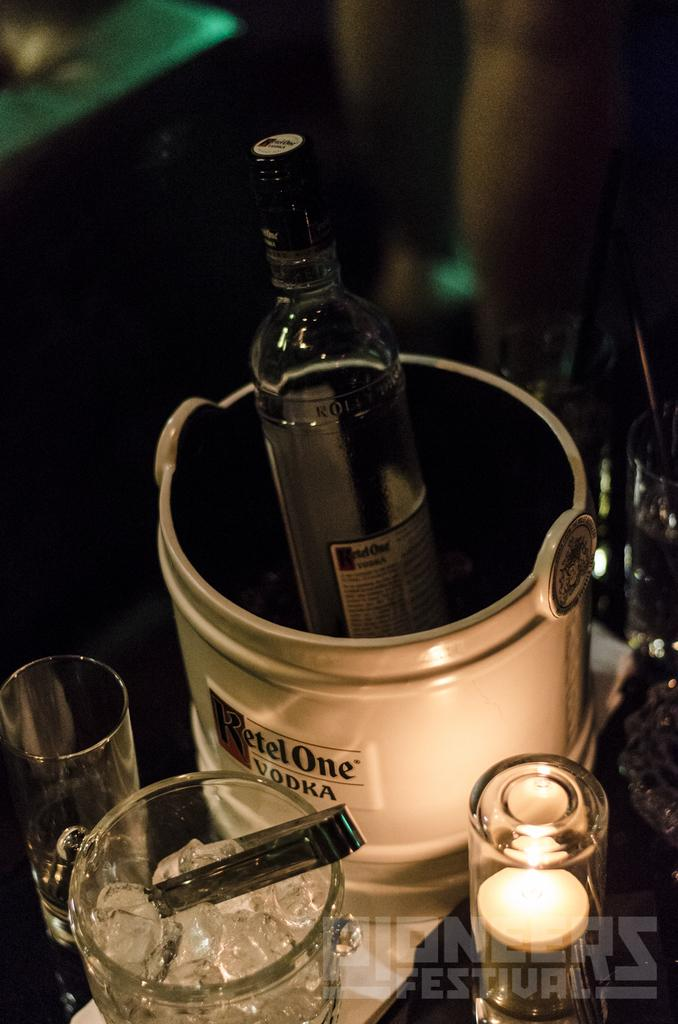What objects are on the table in the image? There is a bottle and a glass on the table in the image. Can you describe the objects on the table? There is a bottle and a glass on the table in the image. How many trees can be seen growing out of the bottle in the image? There are no trees growing out of the bottle in the image. Is there a basketball visible in the image? There is no basketball present in the image. 